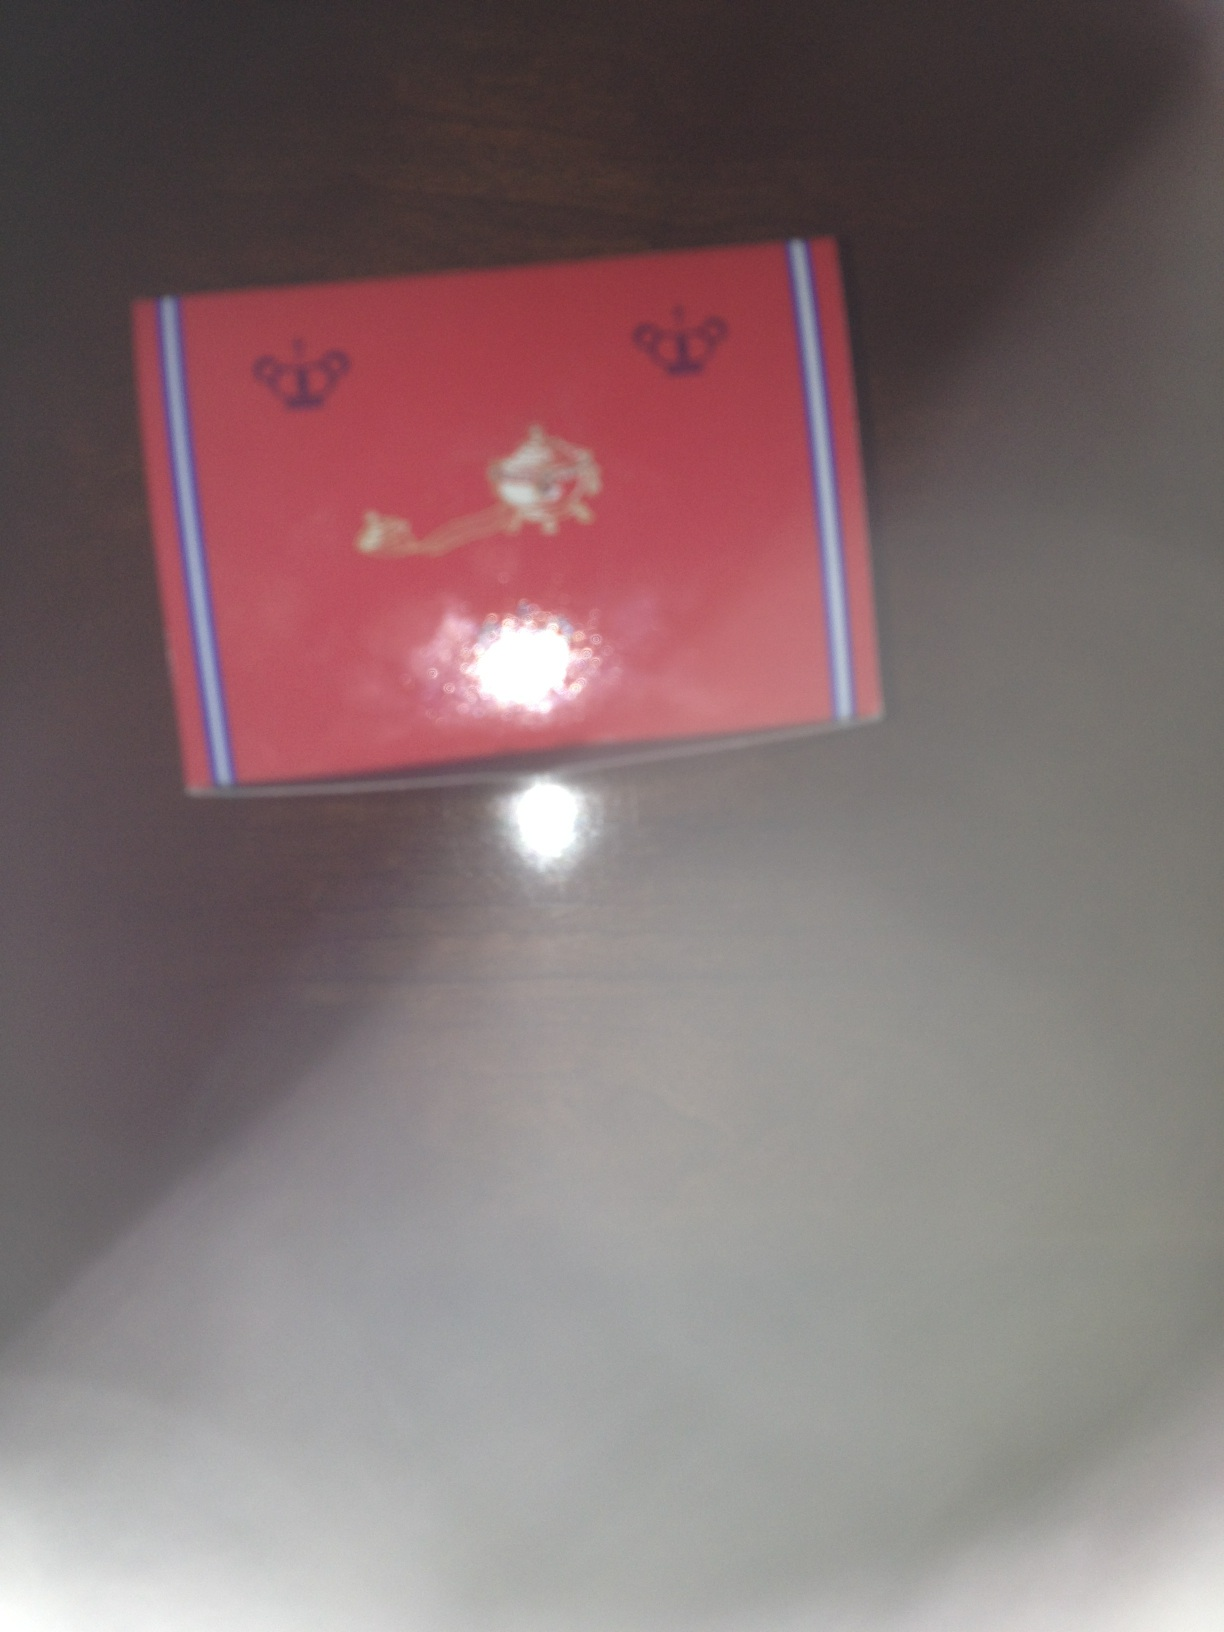Describe a potential real-life scenario in which someone might use this product. A potential scenario where this product might be used is during a lavish party or a high-class event. Picture a grand hall adorned with opulent decorations, where guests dressed in elegant gowns and tuxedos are mingling. Amidst the grandeur, this product could be a gift handed over to the guests, perhaps a luxury item like a designer accessory or an exclusive gourmet treat. What kind of emotions do you think the packaging of this product evokes? The packaging evokes emotions of excitement and anticipation. The red color commands attention and suggests passion and luxury, while the crown motifs hint at elegance and exclusiveness. The overall design creates a sense of curiosity and a desire to uncover what high-value item lies within. Can you come up with a very creative, fantastical use for this item based on its appearance? Imagine this product is a mystical artifact known as the 'Lion's Heart Jewel,' imbued with magical properties capable of granting immense strength and wisdom to its possessor. In a world where mythical creatures and ancient spells are real, this artifact is sought after by brave adventurers and cunning wizards. Wrapped in the iconic red and crown-emblazoned packaging, it is delivered as a royal decree to the chosen one destined to protect the realm from an impending darkness that threatens to engulf the kingdom. 